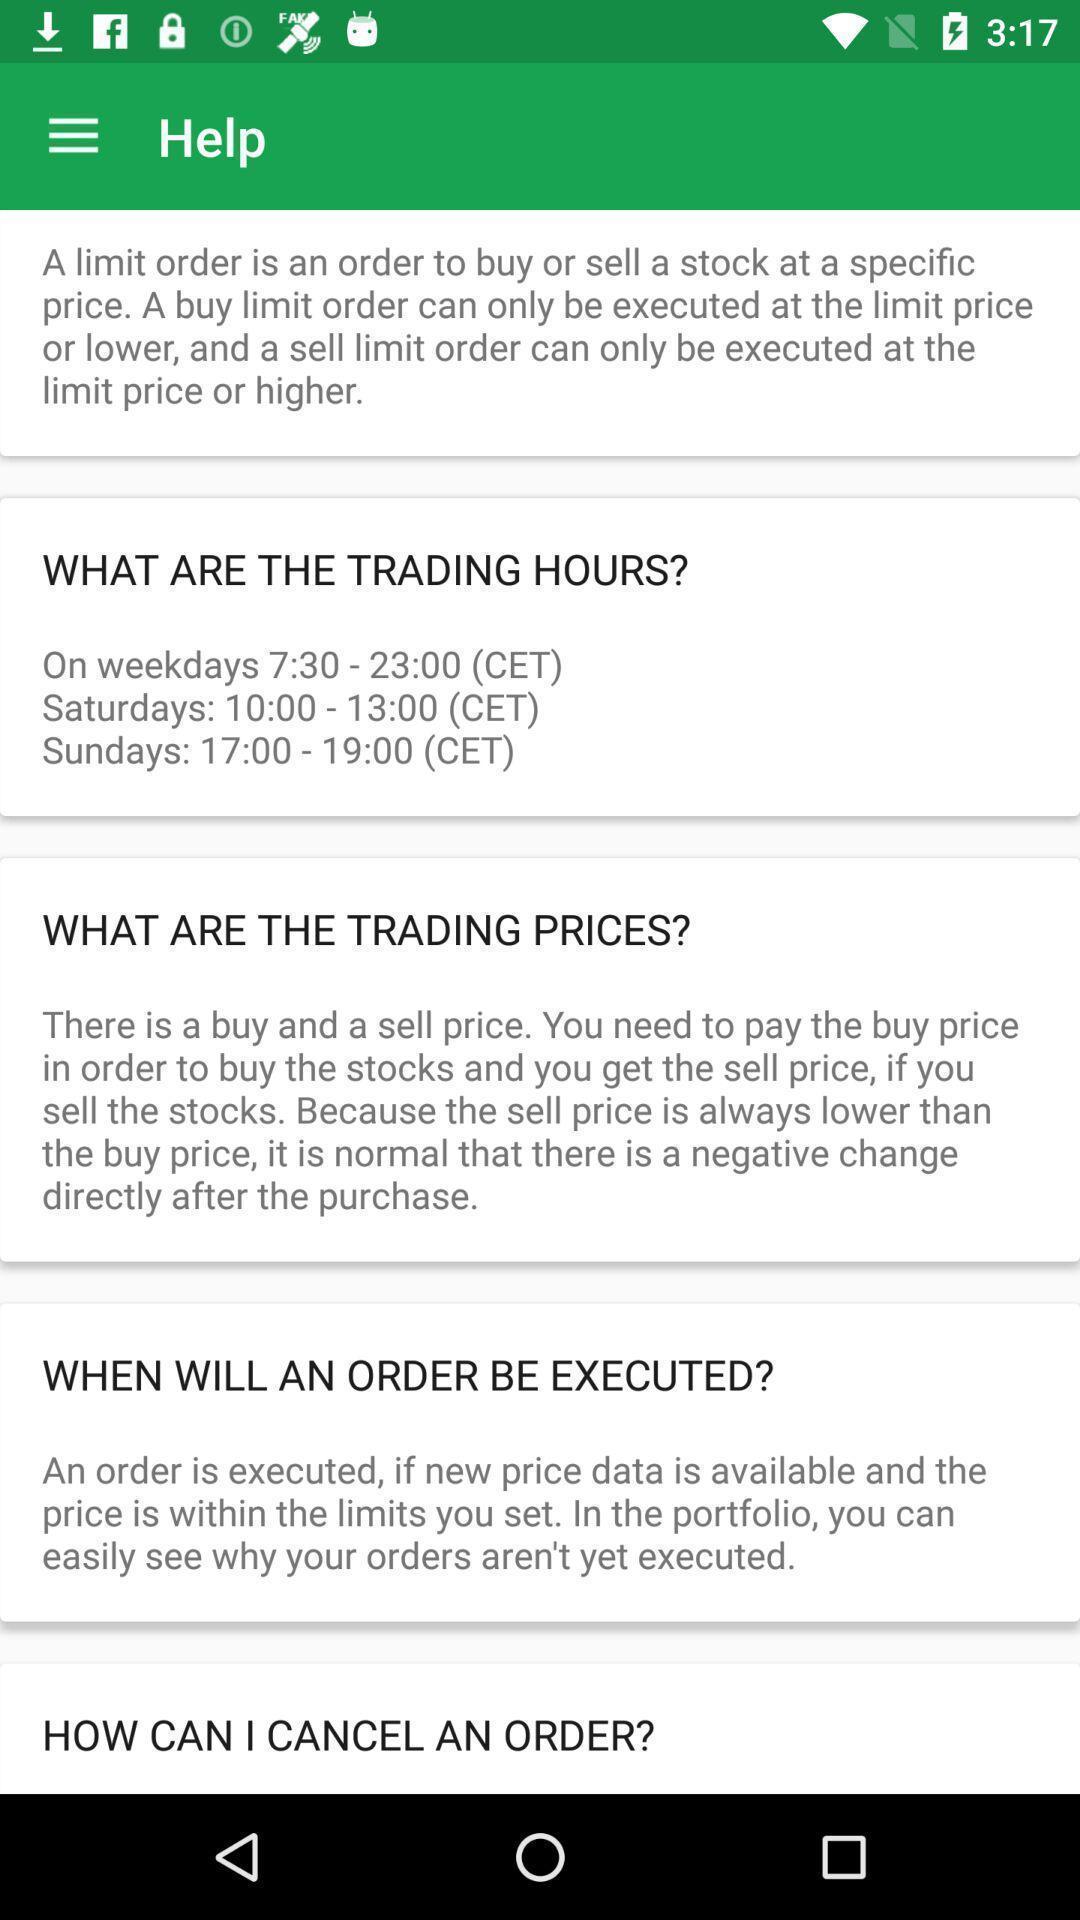Please provide a description for this image. Page displaying information about the app. 